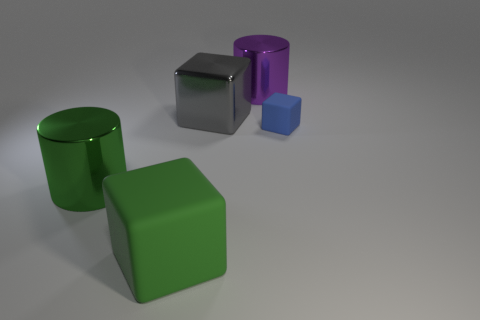There is a rubber block that is the same size as the gray metal object; what color is it?
Your answer should be very brief. Green. The other object that is the same color as the large rubber thing is what shape?
Keep it short and to the point. Cylinder. What number of other things are made of the same material as the tiny object?
Provide a succinct answer. 1. What is the shape of the object that is behind the blue matte block and left of the big purple object?
Ensure brevity in your answer.  Cube. There is a small rubber cube; does it have the same color as the metallic cylinder to the right of the big green matte cube?
Your answer should be very brief. No. There is a green metallic cylinder that is in front of the blue thing; does it have the same size as the purple cylinder?
Your response must be concise. Yes. There is another big thing that is the same shape as the large purple metallic thing; what is its material?
Provide a short and direct response. Metal. Is the small object the same shape as the large purple shiny object?
Provide a short and direct response. No. How many gray objects are to the left of the big thing that is behind the large gray cube?
Your response must be concise. 1. There is a green object that is the same material as the blue block; what shape is it?
Offer a very short reply. Cube. 